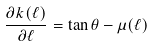Convert formula to latex. <formula><loc_0><loc_0><loc_500><loc_500>\frac { \partial k ( \ell ) } { \partial \ell } = \tan { \theta } - \mu ( \ell )</formula> 